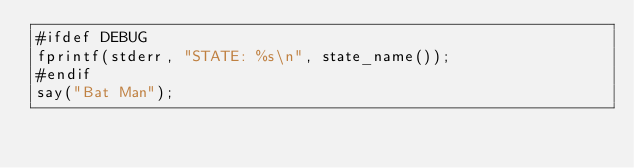Convert code to text. <code><loc_0><loc_0><loc_500><loc_500><_ObjectiveC_>#ifdef DEBUG
fprintf(stderr, "STATE: %s\n", state_name());
#endif
say("Bat Man");</code> 